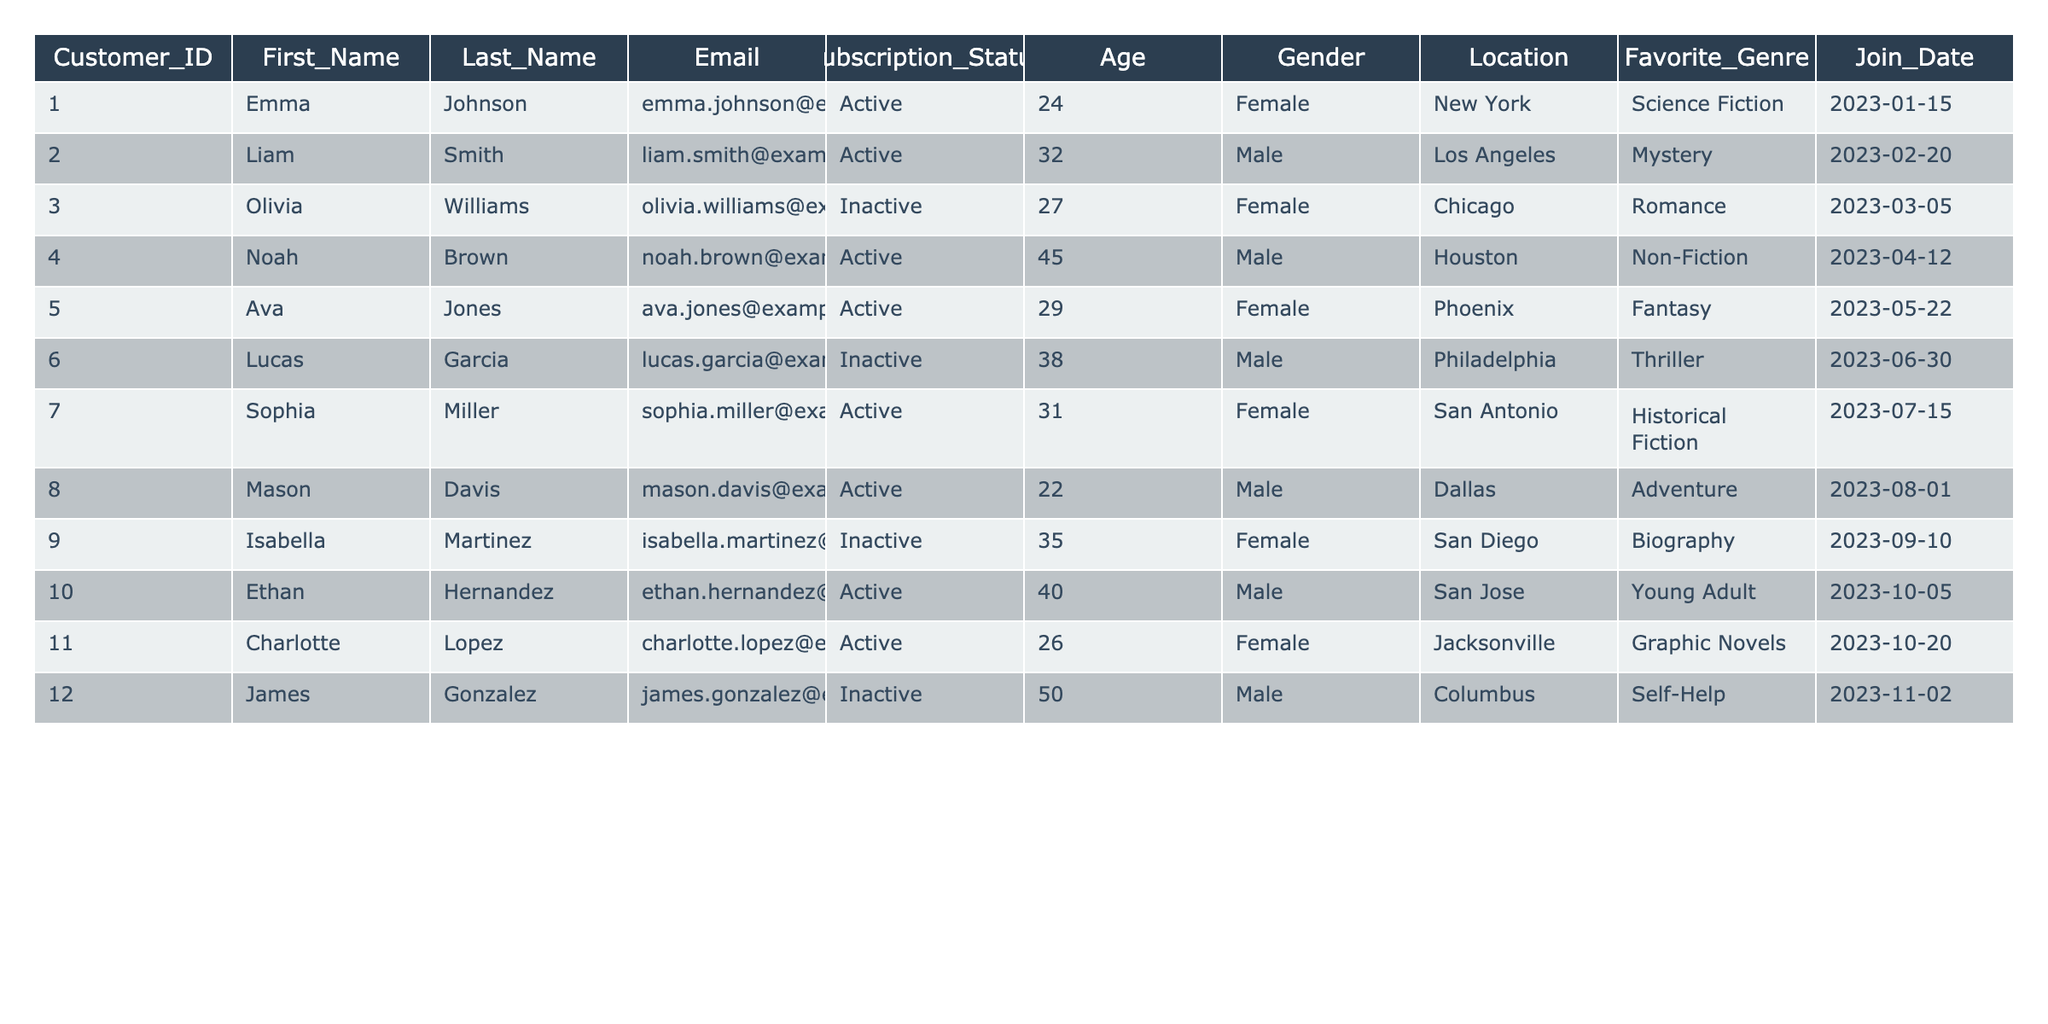What is the Subscription Status of Customer_ID 4? By looking at the table, find the row where Customer_ID is 4. The corresponding Subscription_Status column shows 'Active' for this customer.
Answer: Active How many customers are females? Count the rows in the table where the Gender column is 'Female'. There are 6 rows with 'Female' in the Gender column.
Answer: 6 What is the average age of customers with an Active subscription? First, identify the ages of customers with an Active subscription (24, 32, 45, 29, 31, 22, 40, 26). Then, sum these ages (24 + 32 + 45 + 29 + 31 + 22 + 40 + 26 = 249) and divide by the number of Active customers (8), which gives 249/8 = 31.125.
Answer: 31.125 Is there a customer from San Diego? Check the Location column for 'San Diego'. There is one instance in the table with the corresponding customer (Isabella Martinez) listed in that location.
Answer: Yes Who has the least favorite genre between the Active customers? Review the Favorite_Genre column for Active customers. The options include Science Fiction, Mystery, Non-Fiction, Fantasy, Historical Fiction, Adventure, Young Adult, and Graphic Novels. Identify any least or less popular genre, which isn’t straightforward as the data does not hold popularity statistics; thus, a conclusion cannot be drawn.
Answer: Cannot determine What is the Subscription Status of the oldest customer? Identify the ages in the table (24, 32, 27, 45, 29, 38, 31, 22, 35, 40, 26, 50). The oldest customer is 50 years old (Customer_ID 12) and their Subscription_Status is Inactive.
Answer: Inactive How many customers joined in 2023? Count the rows in the Join_Date column that have the year 2023. All listed customers joined during 2023. There are 12 customers with join dates in 2023.
Answer: 12 Which gender has more Active subscriptions? Count the Active customers for each gender. Active Females: 5 (Emma, Ava, Sophia, Charlotte) and Active Males: 3 (Liam, Noah, Mason, Ethan). Females have more Active subscriptions.
Answer: Female What is the Favorite Genre of Customer_ID 1? Look at the Favorite_Genre column for the customer with Customer_ID 1. The genre listed is 'Science Fiction'.
Answer: Science Fiction How many customers have a subscription status of Inactive and are over the age of 30? Identify the Inactive customers who are over 30 years old. Only Lucas (38) and James (50) fit this criterion. In total, there are 2 such customers.
Answer: 2 